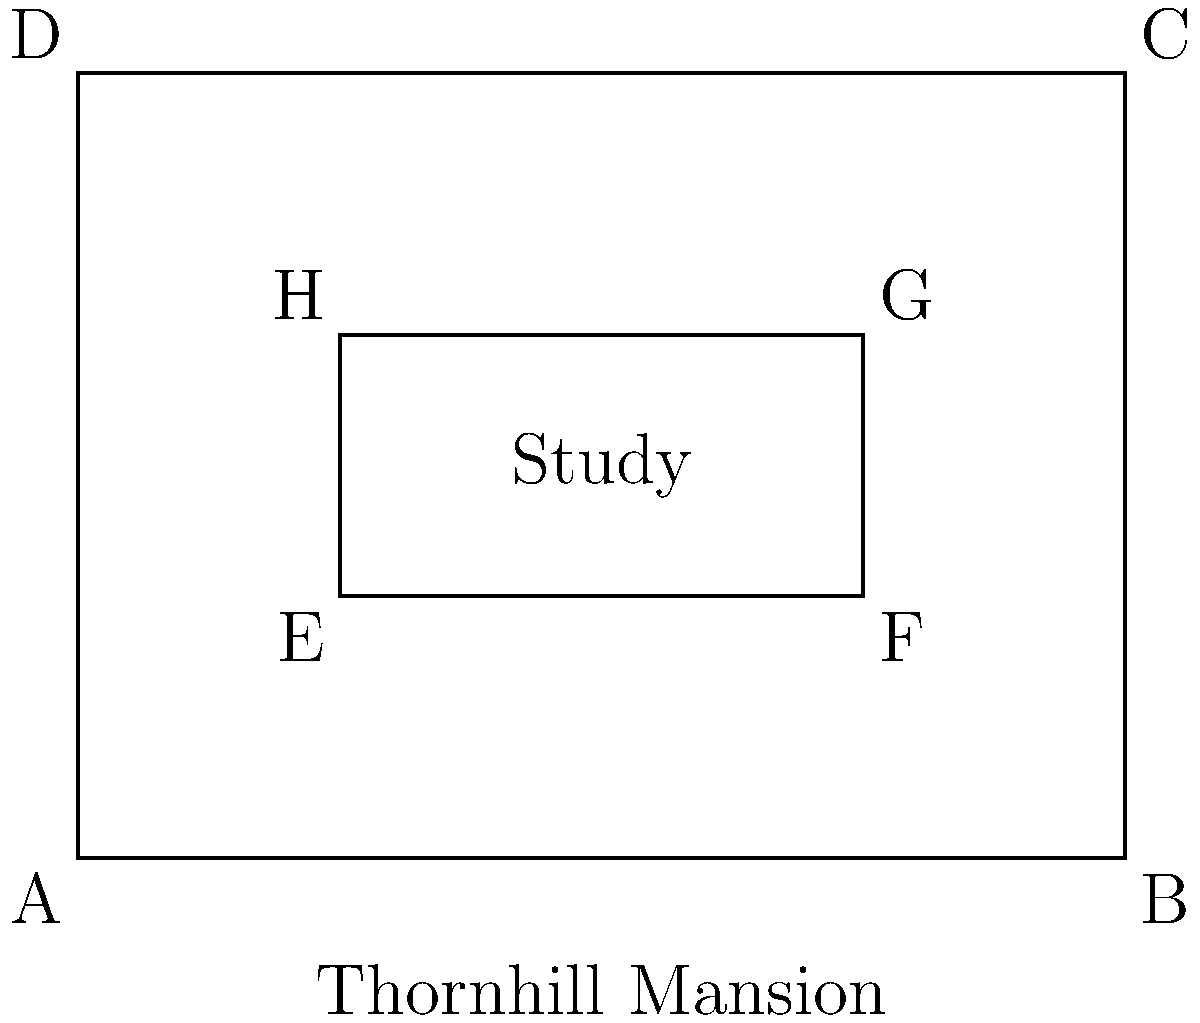In the floor plan of the Blossom family's Thornhill mansion, the study (represented by rectangle EFGH) is congruent to another room in the mansion. If the study has dimensions of 6 feet by 3 feet, what is the area of the entire mansion floor (rectangle ABCD) in square feet? Let's approach this step-by-step:

1) We're told that the study (EFGH) has dimensions of 6 feet by 3 feet. This means:
   EF = FG = 6 feet
   EH = FG = 3 feet

2) The area of the study is therefore:
   Area of study = 6 * 3 = 18 square feet

3) Now, let's look at the entire floor plan (ABCD). We can see that:
   AB is divided into three equal parts (AE, EF, FB)
   AD is divided into three equal parts (AE, EH, HD)

4) Since EF = 6 feet, and it's one-third of AB, we can conclude:
   AB = 6 * 3 = 18 feet

5) Similarly, since EH = 3 feet, and it's one-third of AD, we can conclude:
   AD = 3 * 3 = 9 feet

6) Now we can calculate the area of the entire floor:
   Area of ABCD = AB * AD = 18 * 9 = 162 square feet

Therefore, the area of the entire Thornhill mansion floor is 162 square feet.
Answer: 162 square feet 